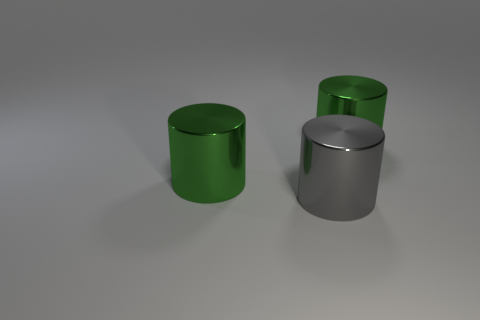Add 2 large green cylinders. How many objects exist? 5 Add 3 big green cylinders. How many big green cylinders exist? 5 Subtract 0 brown cylinders. How many objects are left? 3 Subtract all large red metallic cylinders. Subtract all cylinders. How many objects are left? 0 Add 1 large gray metal cylinders. How many large gray metal cylinders are left? 2 